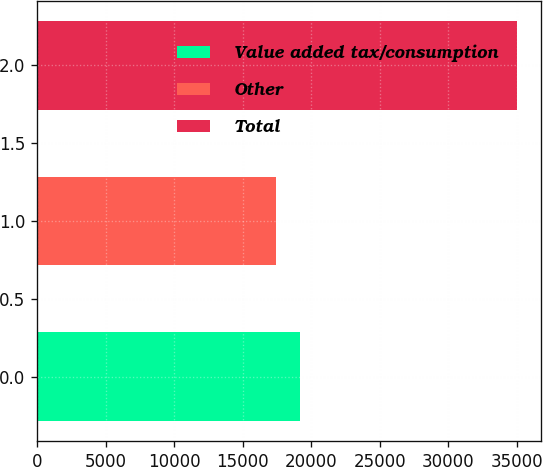<chart> <loc_0><loc_0><loc_500><loc_500><bar_chart><fcel>Value added tax/consumption<fcel>Other<fcel>Total<nl><fcel>19159.6<fcel>17397<fcel>35023<nl></chart> 